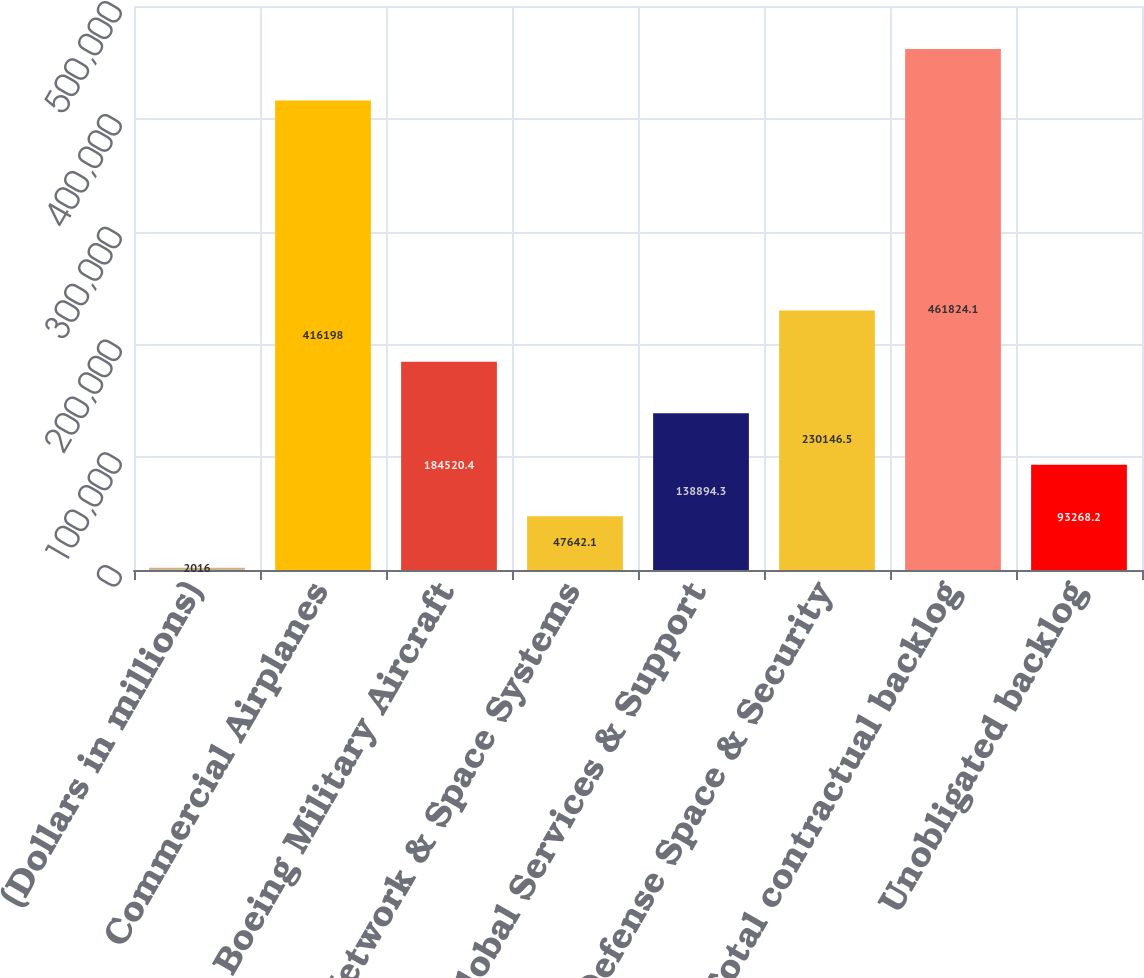<chart> <loc_0><loc_0><loc_500><loc_500><bar_chart><fcel>(Dollars in millions)<fcel>Commercial Airplanes<fcel>Boeing Military Aircraft<fcel>Network & Space Systems<fcel>Global Services & Support<fcel>Total Defense Space & Security<fcel>Total contractual backlog<fcel>Unobligated backlog<nl><fcel>2016<fcel>416198<fcel>184520<fcel>47642.1<fcel>138894<fcel>230146<fcel>461824<fcel>93268.2<nl></chart> 